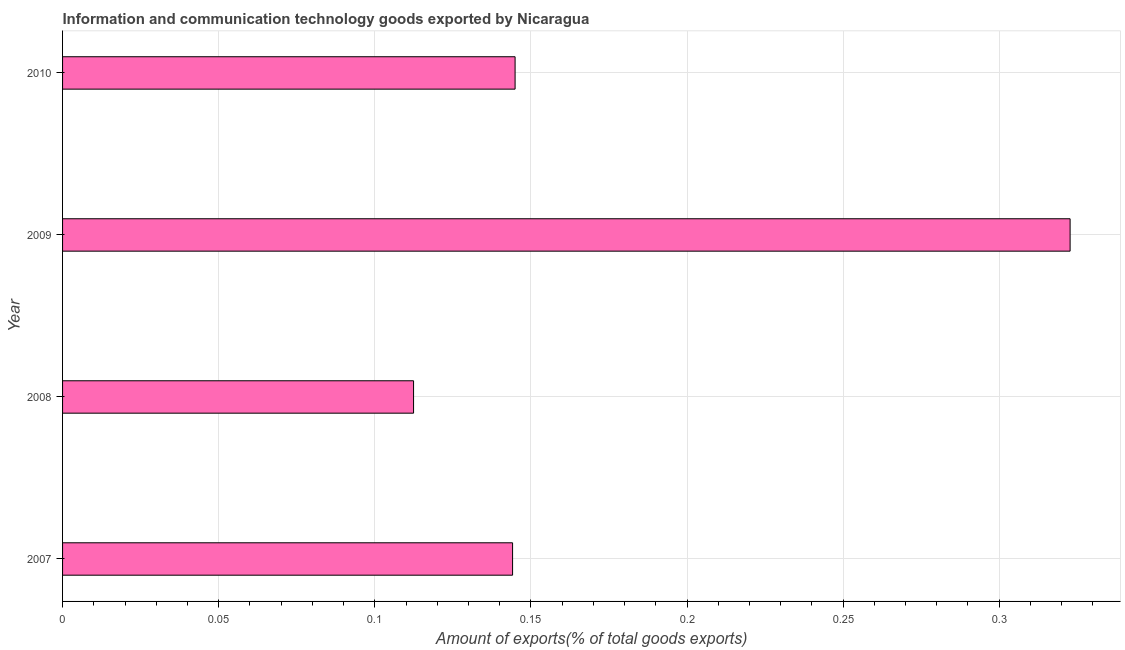What is the title of the graph?
Your response must be concise. Information and communication technology goods exported by Nicaragua. What is the label or title of the X-axis?
Provide a succinct answer. Amount of exports(% of total goods exports). What is the label or title of the Y-axis?
Ensure brevity in your answer.  Year. What is the amount of ict goods exports in 2009?
Give a very brief answer. 0.32. Across all years, what is the maximum amount of ict goods exports?
Your answer should be very brief. 0.32. Across all years, what is the minimum amount of ict goods exports?
Your answer should be compact. 0.11. What is the sum of the amount of ict goods exports?
Provide a short and direct response. 0.72. What is the difference between the amount of ict goods exports in 2008 and 2010?
Offer a terse response. -0.03. What is the average amount of ict goods exports per year?
Your answer should be compact. 0.18. What is the median amount of ict goods exports?
Provide a short and direct response. 0.14. In how many years, is the amount of ict goods exports greater than 0.08 %?
Offer a very short reply. 4. Do a majority of the years between 2008 and 2010 (inclusive) have amount of ict goods exports greater than 0.25 %?
Offer a terse response. No. What is the ratio of the amount of ict goods exports in 2009 to that in 2010?
Provide a succinct answer. 2.23. Is the amount of ict goods exports in 2008 less than that in 2009?
Make the answer very short. Yes. What is the difference between the highest and the second highest amount of ict goods exports?
Your answer should be very brief. 0.18. What is the difference between the highest and the lowest amount of ict goods exports?
Your answer should be compact. 0.21. In how many years, is the amount of ict goods exports greater than the average amount of ict goods exports taken over all years?
Your answer should be very brief. 1. Are all the bars in the graph horizontal?
Make the answer very short. Yes. How many years are there in the graph?
Offer a terse response. 4. What is the difference between two consecutive major ticks on the X-axis?
Your answer should be compact. 0.05. Are the values on the major ticks of X-axis written in scientific E-notation?
Offer a very short reply. No. What is the Amount of exports(% of total goods exports) of 2007?
Your response must be concise. 0.14. What is the Amount of exports(% of total goods exports) in 2008?
Provide a short and direct response. 0.11. What is the Amount of exports(% of total goods exports) of 2009?
Ensure brevity in your answer.  0.32. What is the Amount of exports(% of total goods exports) of 2010?
Your response must be concise. 0.14. What is the difference between the Amount of exports(% of total goods exports) in 2007 and 2008?
Offer a terse response. 0.03. What is the difference between the Amount of exports(% of total goods exports) in 2007 and 2009?
Offer a very short reply. -0.18. What is the difference between the Amount of exports(% of total goods exports) in 2007 and 2010?
Provide a succinct answer. -0. What is the difference between the Amount of exports(% of total goods exports) in 2008 and 2009?
Your answer should be very brief. -0.21. What is the difference between the Amount of exports(% of total goods exports) in 2008 and 2010?
Your answer should be compact. -0.03. What is the difference between the Amount of exports(% of total goods exports) in 2009 and 2010?
Ensure brevity in your answer.  0.18. What is the ratio of the Amount of exports(% of total goods exports) in 2007 to that in 2008?
Ensure brevity in your answer.  1.28. What is the ratio of the Amount of exports(% of total goods exports) in 2007 to that in 2009?
Your answer should be compact. 0.45. What is the ratio of the Amount of exports(% of total goods exports) in 2007 to that in 2010?
Give a very brief answer. 0.99. What is the ratio of the Amount of exports(% of total goods exports) in 2008 to that in 2009?
Offer a very short reply. 0.35. What is the ratio of the Amount of exports(% of total goods exports) in 2008 to that in 2010?
Ensure brevity in your answer.  0.78. What is the ratio of the Amount of exports(% of total goods exports) in 2009 to that in 2010?
Your answer should be very brief. 2.23. 